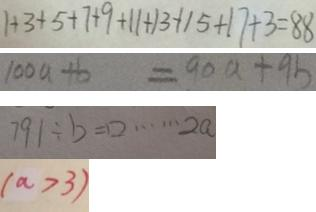Convert formula to latex. <formula><loc_0><loc_0><loc_500><loc_500>1 + 3 + 5 + 7 + 9 + 1 1 + 1 3 + 1 5 + 1 7 + 3 = 8 8 
 1 0 0 a + b = 9 0 a + 9 b 
 7 9 1 \div b = \square \cdots 2 a 
 ( a > 3 )</formula> 